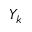<formula> <loc_0><loc_0><loc_500><loc_500>Y _ { k }</formula> 